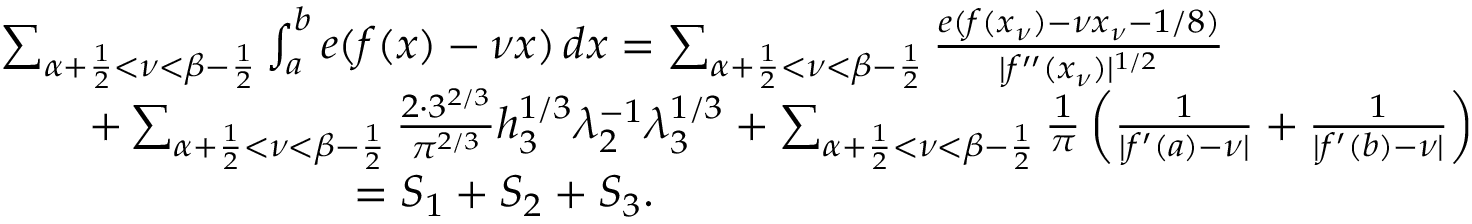<formula> <loc_0><loc_0><loc_500><loc_500>\begin{array} { r l } & { \sum _ { \alpha + \frac { 1 } { 2 } < \nu < \beta - \frac { 1 } { 2 } } \int _ { a } ^ { b } e ( f ( x ) - \nu x ) \, d x = \sum _ { \alpha + \frac { 1 } { 2 } < \nu < \beta - \frac { 1 } { 2 } } \frac { e ( f ( x _ { \nu } ) - \nu x _ { \nu } - 1 / 8 ) } { | f ^ { \prime \prime } ( x _ { \nu } ) | ^ { 1 / 2 } } } \\ & { \quad + \sum _ { \alpha + \frac { 1 } { 2 } < \nu < \beta - \frac { 1 } { 2 } } \frac { 2 \cdot 3 ^ { 2 / 3 } } { \pi ^ { 2 / 3 } } h _ { 3 } ^ { 1 / 3 } \lambda _ { 2 } ^ { - 1 } \lambda _ { 3 } ^ { 1 / 3 } + \sum _ { \alpha + \frac { 1 } { 2 } < \nu < \beta - \frac { 1 } { 2 } } \frac { 1 } { \pi } \left ( \frac { 1 } { | f ^ { \prime } ( a ) - \nu | } + \frac { 1 } { | f ^ { \prime } ( b ) - \nu | } \right ) } \\ & { \quad = S _ { 1 } + S _ { 2 } + S _ { 3 } . } \end{array}</formula> 